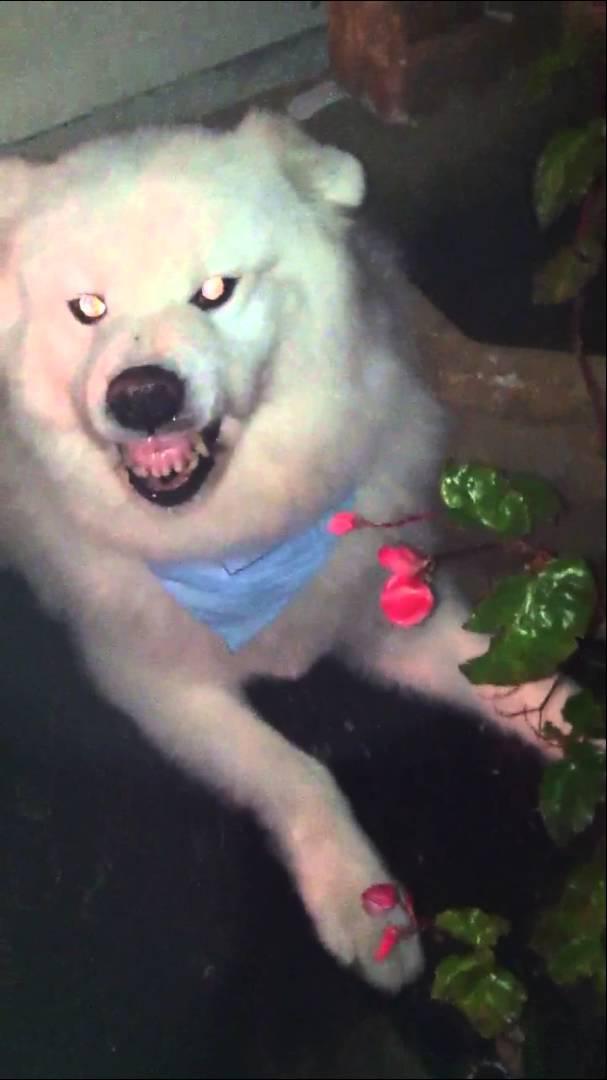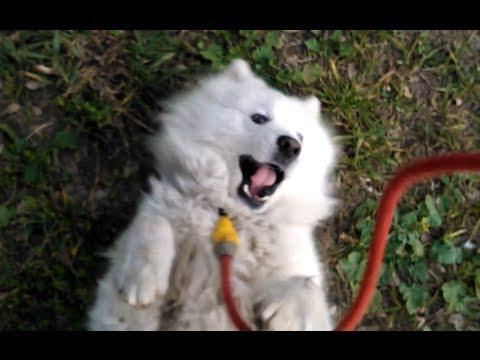The first image is the image on the left, the second image is the image on the right. Considering the images on both sides, is "There's at least one angry dog showing its teeth in the image pair." valid? Answer yes or no. Yes. The first image is the image on the left, the second image is the image on the right. Analyze the images presented: Is the assertion "An image shows an open-mouthed white dog with tongue showing and a non-fierce expression." valid? Answer yes or no. Yes. 